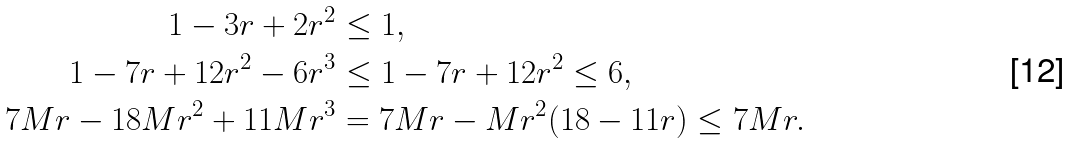Convert formula to latex. <formula><loc_0><loc_0><loc_500><loc_500>1 - 3 r + 2 r ^ { 2 } & \leq 1 , \\ 1 - 7 r + 1 2 r ^ { 2 } - 6 r ^ { 3 } & \leq 1 - 7 r + 1 2 r ^ { 2 } \leq 6 , \\ 7 M r - 1 8 M r ^ { 2 } + 1 1 M r ^ { 3 } & = 7 M r - M r ^ { 2 } ( 1 8 - 1 1 r ) \leq 7 M r .</formula> 